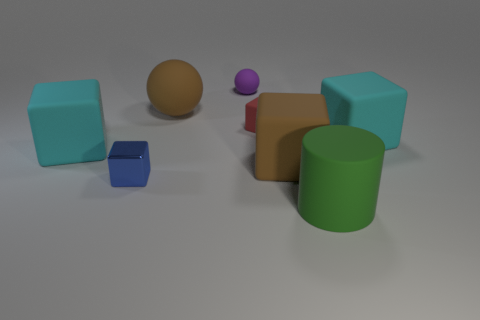Is there anything else that has the same material as the small blue thing?
Offer a terse response. No. How many brown matte things have the same shape as the tiny blue thing?
Provide a short and direct response. 1. What shape is the other rubber thing that is the same size as the purple matte object?
Give a very brief answer. Cube. There is a large brown ball; are there any large brown rubber things in front of it?
Offer a terse response. Yes. There is a big cube that is to the left of the small blue shiny cube; are there any big matte balls to the left of it?
Keep it short and to the point. No. Are there fewer small blue metallic cubes on the right side of the big green rubber cylinder than matte things that are in front of the small matte cube?
Your answer should be compact. Yes. Are there any other things that have the same size as the blue metal block?
Make the answer very short. Yes. The purple thing has what shape?
Provide a short and direct response. Sphere. There is a brown object that is in front of the red rubber thing; what is its material?
Ensure brevity in your answer.  Rubber. How big is the rubber thing behind the big object that is behind the block right of the brown matte block?
Ensure brevity in your answer.  Small. 